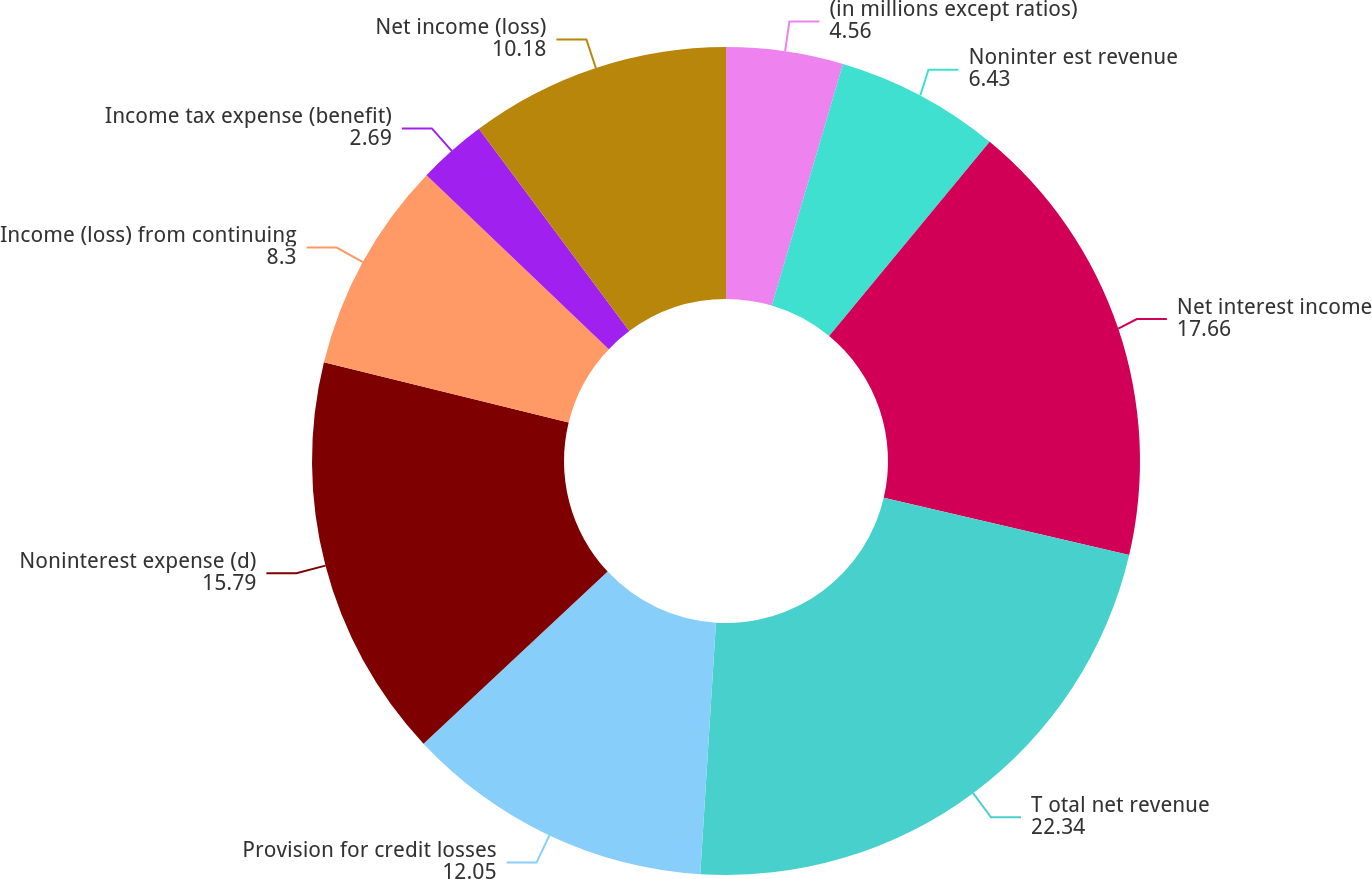Convert chart. <chart><loc_0><loc_0><loc_500><loc_500><pie_chart><fcel>(in millions except ratios)<fcel>Noninter est revenue<fcel>Net interest income<fcel>T otal net revenue<fcel>Provision for credit losses<fcel>Noninterest expense (d)<fcel>Income (loss) from continuing<fcel>Income tax expense (benefit)<fcel>Net income (loss)<nl><fcel>4.56%<fcel>6.43%<fcel>17.66%<fcel>22.34%<fcel>12.05%<fcel>15.79%<fcel>8.3%<fcel>2.69%<fcel>10.18%<nl></chart> 